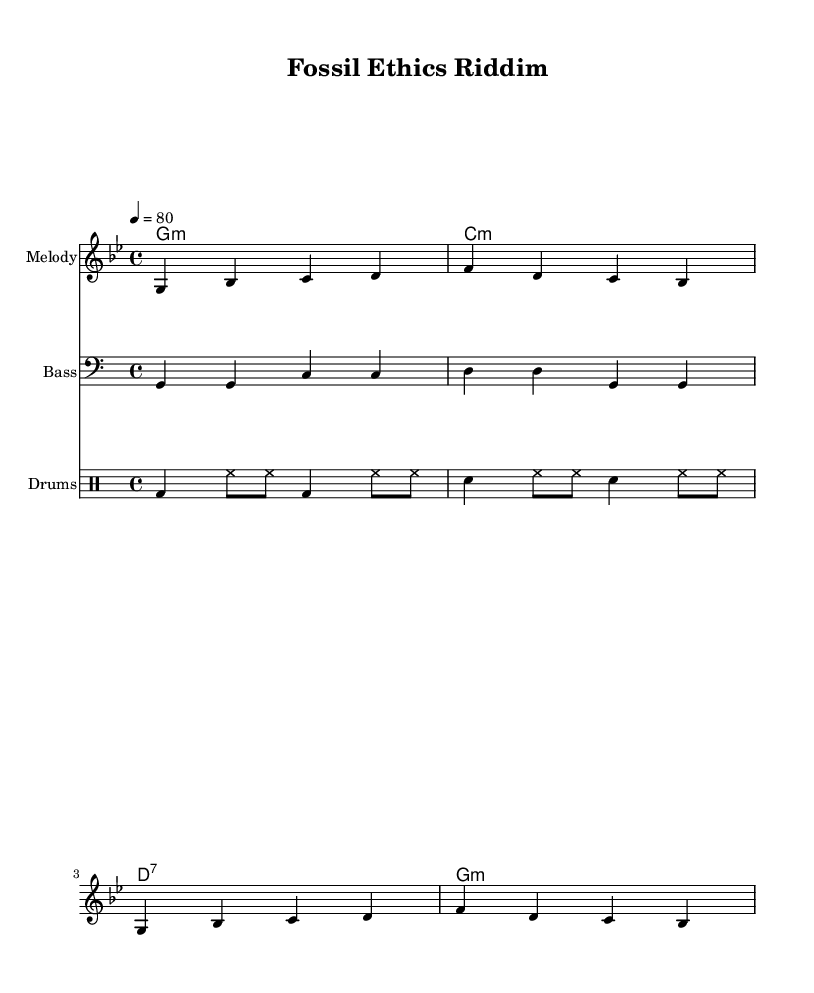What is the key signature of this music? The key signature is G minor, indicated by the presence of two flats (B♭ and E♭) in the music sheet.
Answer: G minor What is the time signature of this music? The time signature is indicated at the beginning of the score as 4/4, meaning there are four beats in each measure and a quarter note gets one beat.
Answer: 4/4 What is the tempo marking of this music? The tempo marking is indicated as "4 = 80," meaning that there are 80 beats per minute, and four beats in each measure correspond to the quarter note.
Answer: 80 How many measures are in the melody section? There are four measures in the melody section, numbered distinctively as each line of notes is grouped into measures separated by vertical lines.
Answer: Four measures What rhythmic pattern is used in the drums part? The drum part comprises a pattern featuring bass drum and snare drum rhythms interspersed with hi-hat sounds, which is typical in reggae music's emphasis on offbeat rhythms.
Answer: Offbeat rhythm What type of lyrical theme is represented in the text? The lyrics highlight ethical considerations in paleontological research, discussing care and responsibility in the exploration of the past, reflecting on broader social issues within the field.
Answer: Ethical considerations What is the role of the bass line in reggae music? The bass line provides a foundational groove and rhythm that is central to reggae music, often playing syncopated patterns to accentuate the off-beat feel typical of the genre.
Answer: Foundation of groove 